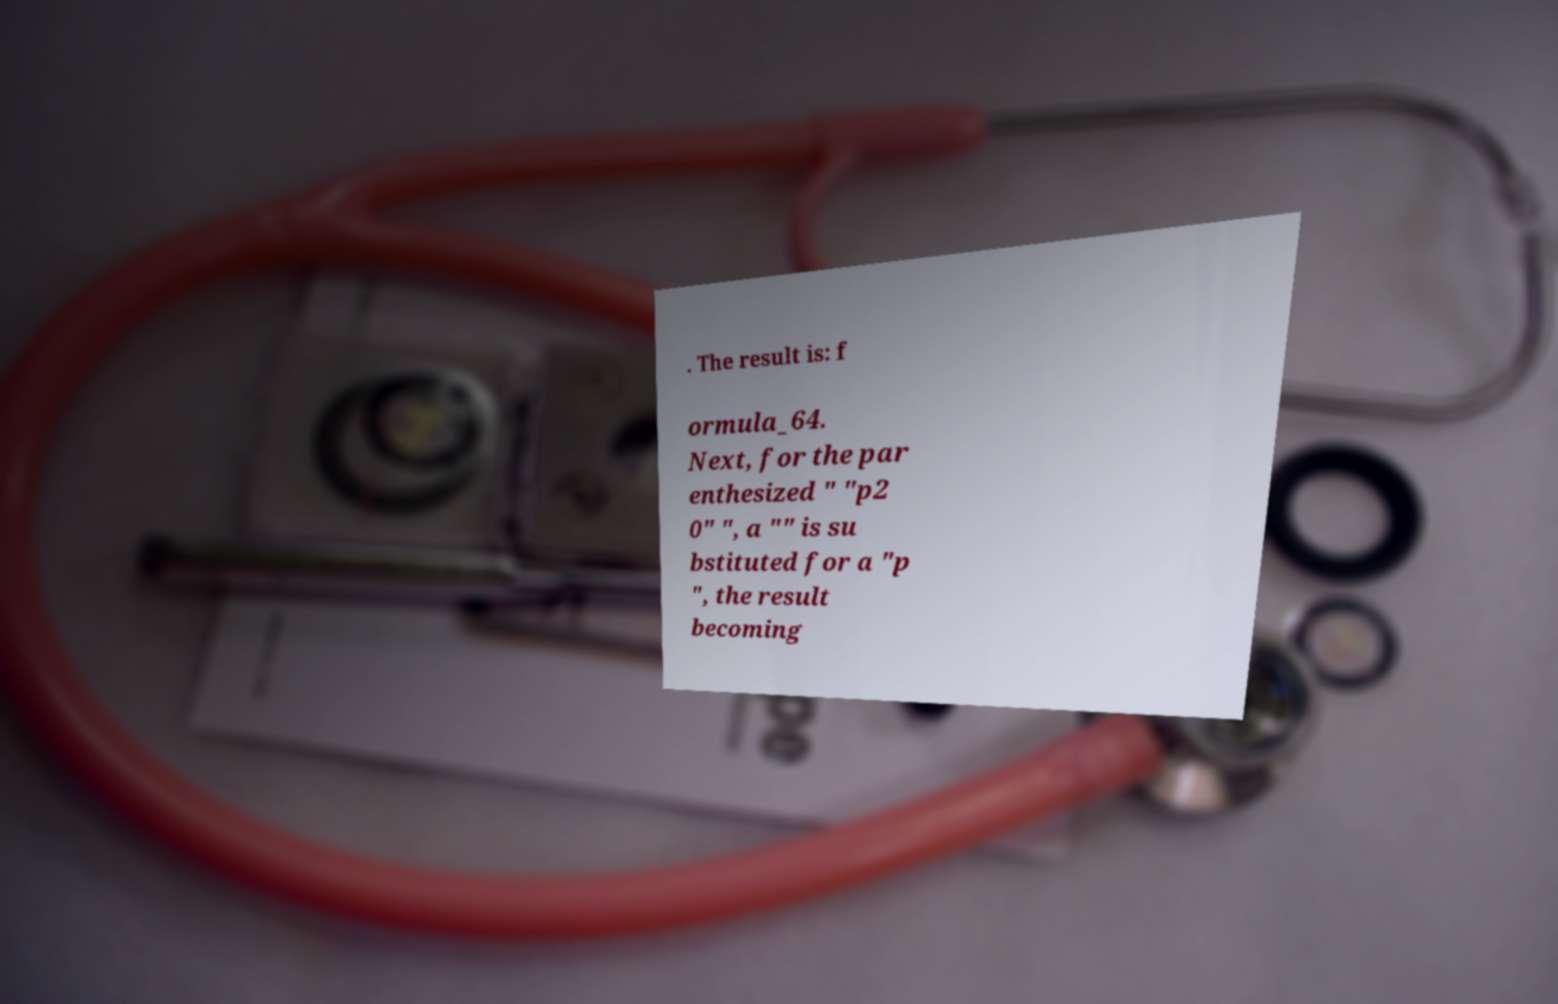Can you accurately transcribe the text from the provided image for me? . The result is: f ormula_64. Next, for the par enthesized " "p2 0" ", a "" is su bstituted for a "p ", the result becoming 